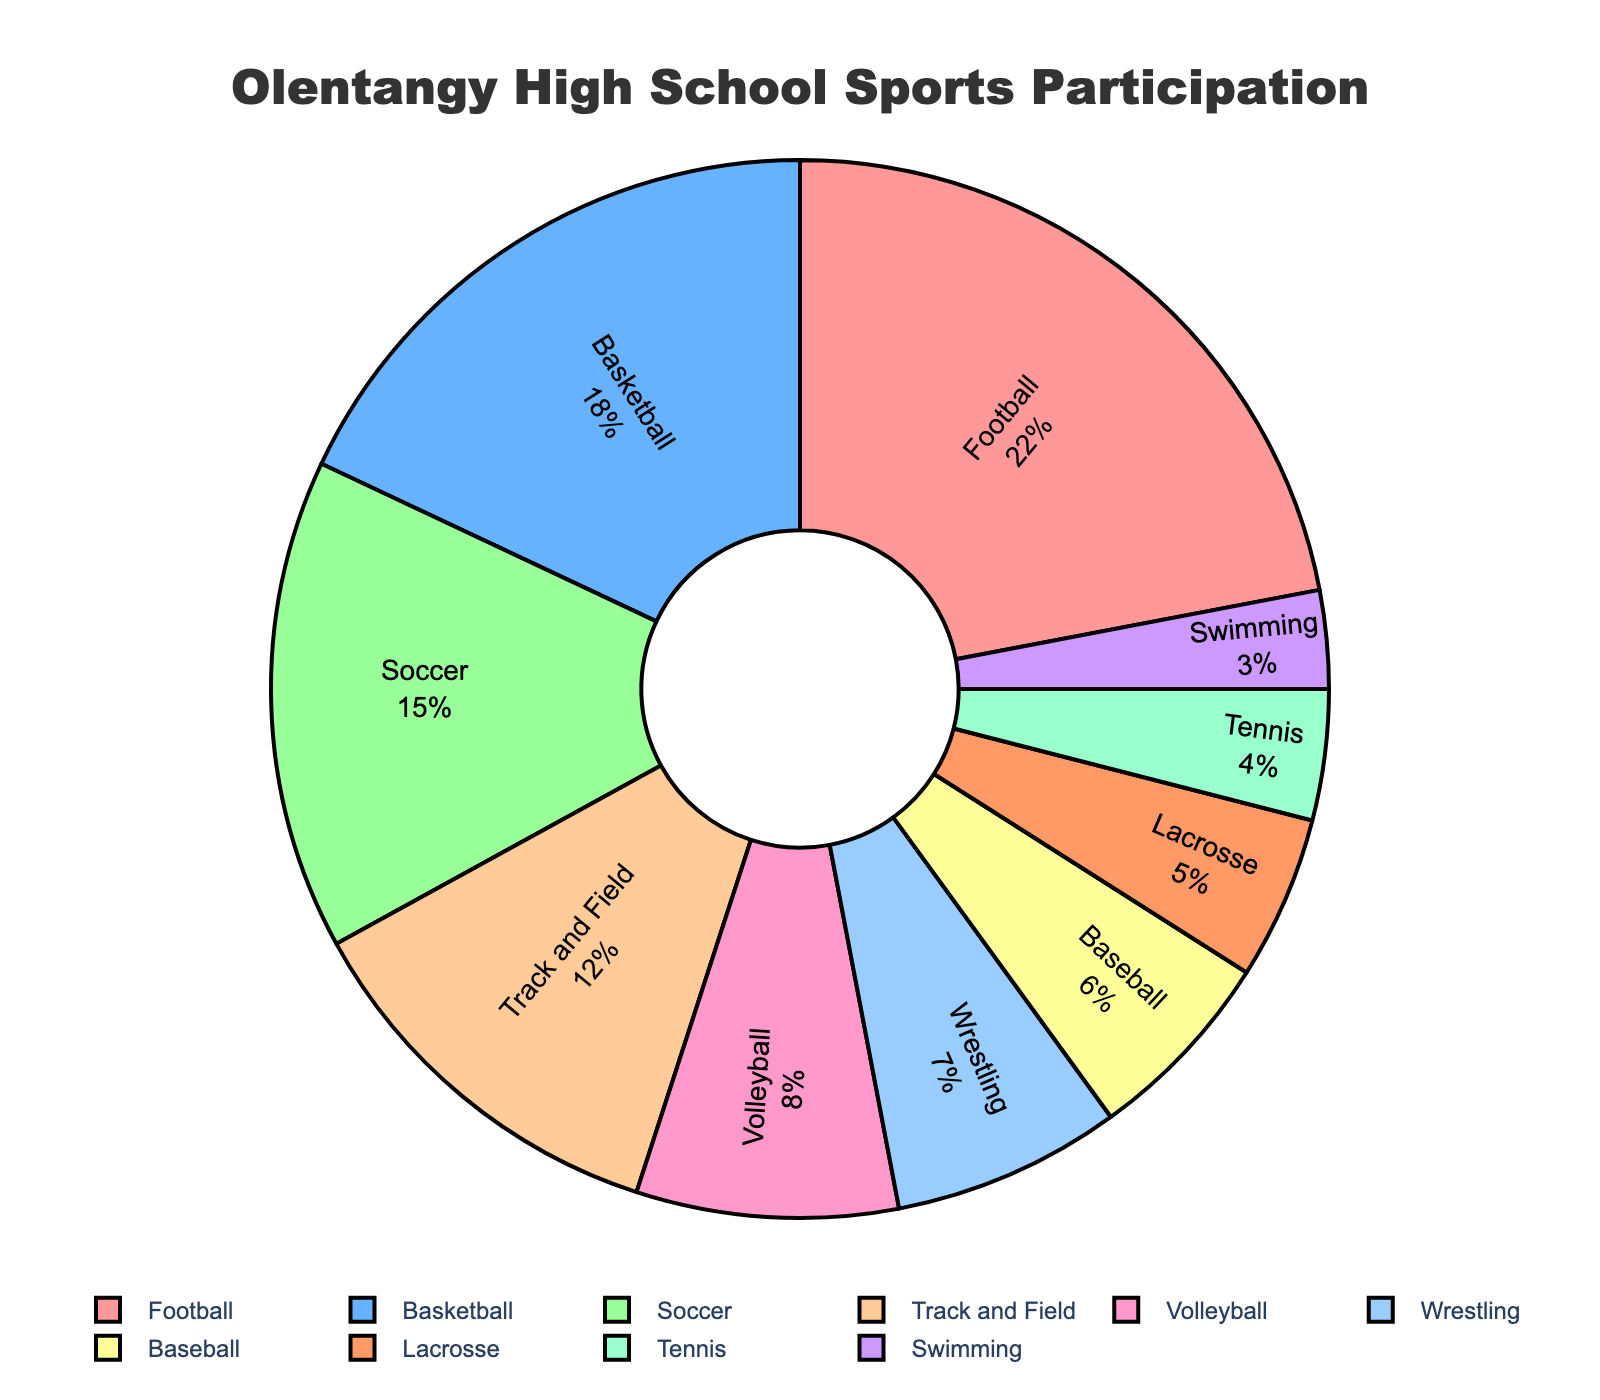Which sport has the highest participation percentage? The pie chart shows that Football has the largest segment, which is the highest percentage among all the sports.
Answer: Football Are there more students participating in Basketball or Soccer? By observing the pie chart, the segment for Basketball is larger than the segment for Soccer. This means more students participate in Basketball than in Soccer.
Answer: Basketball How many percentage points higher is Volleyball participation compared to Wrestling? Volleyball accounts for 8% of participation, while Wrestling accounts for 7%. The difference between these two percentages is calculated by subtracting 7 from 8.
Answer: 1 What is the combined percentage of students participating in Track and Field, Volleyball, and Wrestling? Adding the segments for Track and Field (12%), Volleyball (8%), and Wrestling (7%) together gives us the total percentage: 12 + 8 + 7.
Answer: 27 Which sports have a participation percentage less than 10%? Observing the pie chart, the segments for Volleyball (8%), Wrestling (7%), Baseball (6%), Lacrosse (5%), Tennis (4%), and Swimming (3%) are all less than 10%.
Answer: Volleyball, Wrestling, Baseball, Lacrosse, Tennis, Swimming What is the difference in participation percentage between the sport with the highest participation and the sport with the lowest participation? The sport with the highest participation is Football at 22%, and the sport with the lowest is Swimming at 3%. Subtracting 3 from 22 gives us the difference.
Answer: 19 In terms of participation percentages, which sport is positioned closest to Basketball? The pie chart shows that Soccer, with a 15% segment, is closest to Basketball's 18% segment.
Answer: Soccer What percentage of students participate in Baseball and Lacrosse combined? Adding the Baseball segment (6%) and the Lacrosse segment (5%) together gives us the total percentage: 6 + 5.
Answer: 11 How do the participation percentages of Tennis and Swimming compare? The pie chart segments for Tennis and Swimming show that Tennis (4%) has a higher participation percentage compared to Swimming (3%).
Answer: Tennis What is the average participation percentage of the top three sports? The top three sports are Football (22%), Basketball (18%), and Soccer (15%). Adding these together: 22 + 18 + 15 = 55, and dividing by 3 gives the average: 55 / 3.
Answer: 18.33 